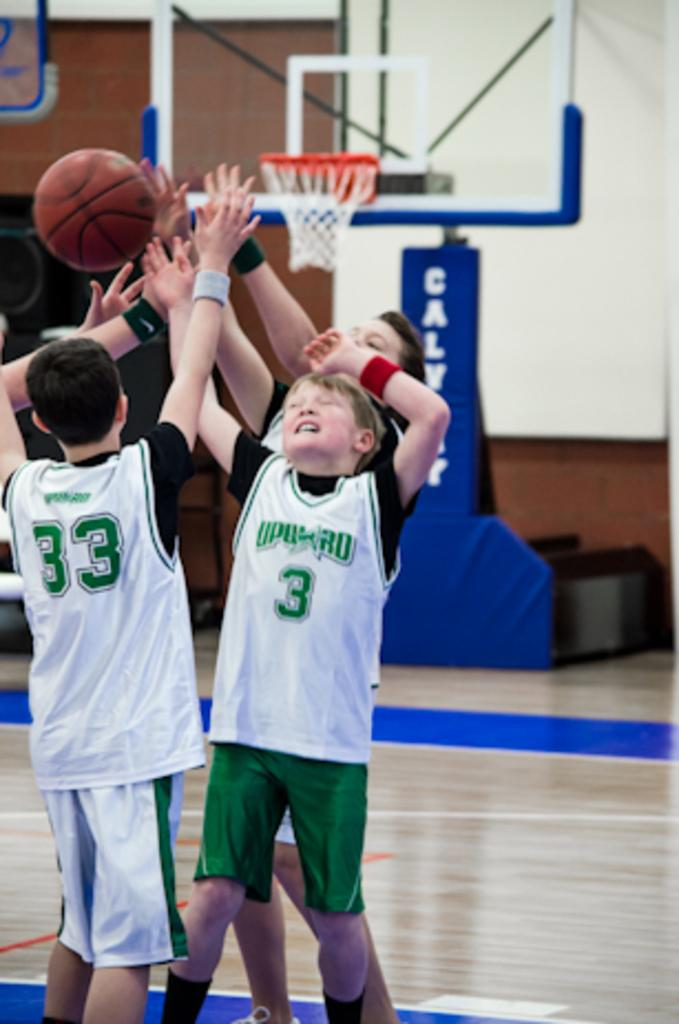What are the kids in the image doing? The kids are playing with a ball in the image. What is the purpose of the basketball hoop behind the kids? The basketball hoop is likely used for playing basketball. What is located behind the basketball hoop? There is a wall behind the basketball hoop. What type of sand can be seen near the volcano in the image? There is no sand or volcano present in the image; it features a group of kids playing with a ball and a basketball hoop. 